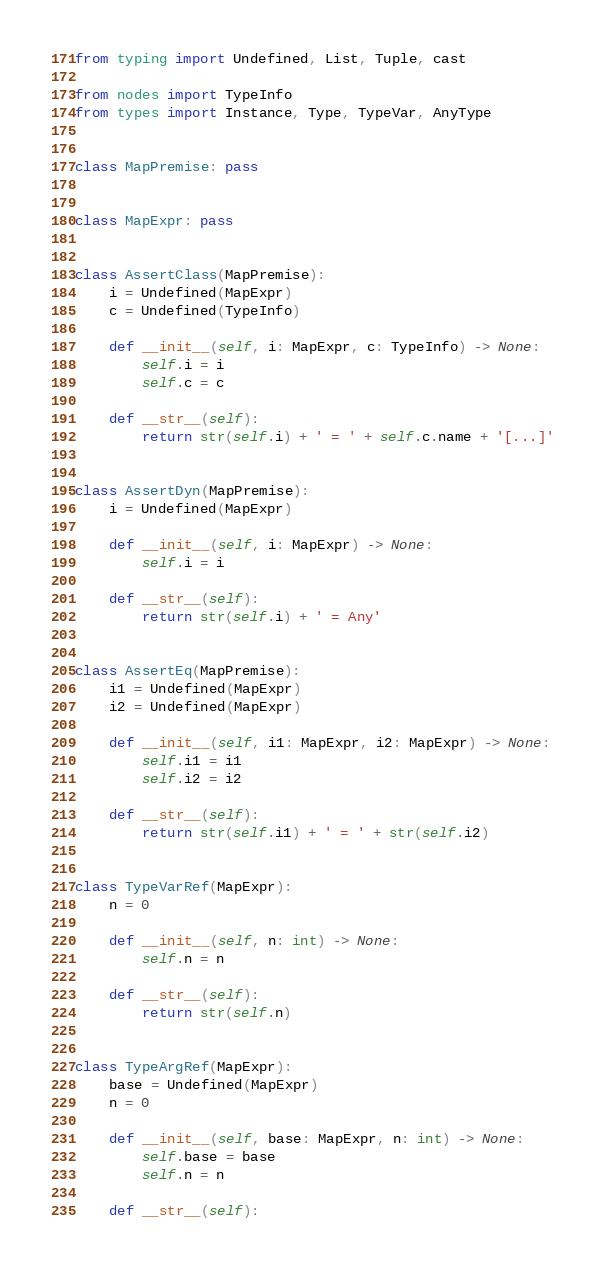<code> <loc_0><loc_0><loc_500><loc_500><_Python_>from typing import Undefined, List, Tuple, cast

from nodes import TypeInfo
from types import Instance, Type, TypeVar, AnyType


class MapPremise: pass


class MapExpr: pass


class AssertClass(MapPremise):
    i = Undefined(MapExpr)
    c = Undefined(TypeInfo)

    def __init__(self, i: MapExpr, c: TypeInfo) -> None:
        self.i = i
        self.c = c

    def __str__(self):
        return str(self.i) + ' = ' + self.c.name + '[...]'


class AssertDyn(MapPremise):
    i = Undefined(MapExpr)

    def __init__(self, i: MapExpr) -> None:
        self.i = i

    def __str__(self):
        return str(self.i) + ' = Any'


class AssertEq(MapPremise):
    i1 = Undefined(MapExpr)
    i2 = Undefined(MapExpr)

    def __init__(self, i1: MapExpr, i2: MapExpr) -> None:
        self.i1 = i1
        self.i2 = i2

    def __str__(self):
        return str(self.i1) + ' = ' + str(self.i2)


class TypeVarRef(MapExpr):
    n = 0

    def __init__(self, n: int) -> None:
        self.n = n

    def __str__(self):
        return str(self.n)


class TypeArgRef(MapExpr):
    base = Undefined(MapExpr)
    n = 0

    def __init__(self, base: MapExpr, n: int) -> None:
        self.base = base
        self.n = n

    def __str__(self):</code> 